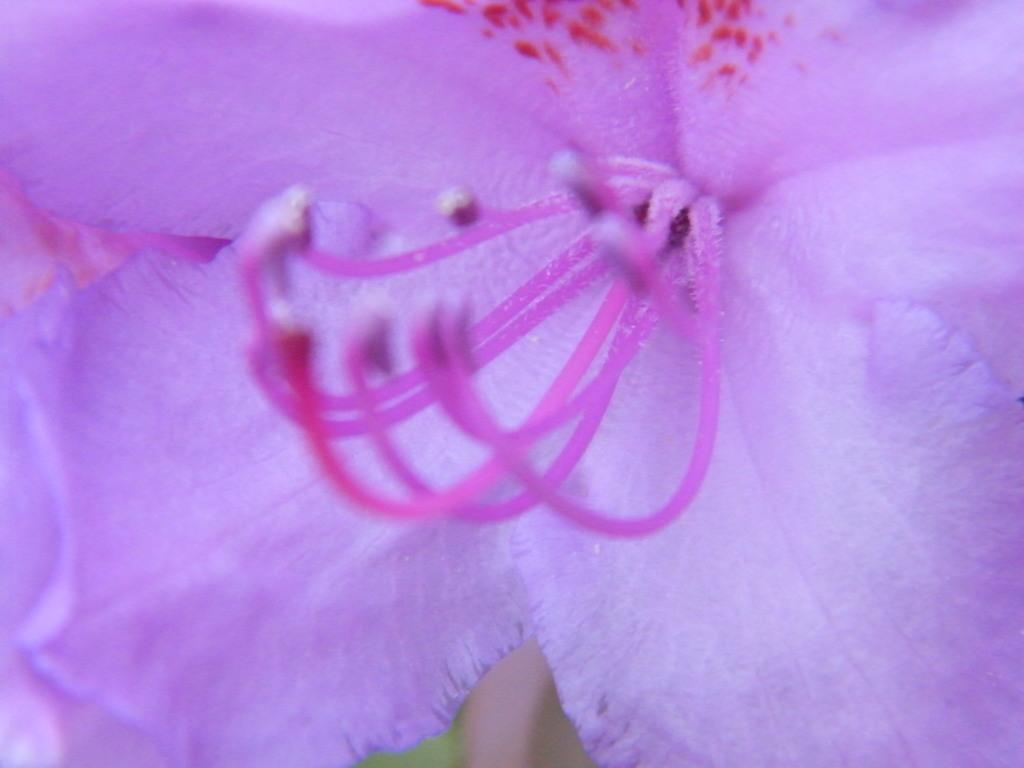What type of plant is depicted in the image? There is a flower with stamens in the image. What other part of the plant can be seen in the image? There is a green object that resembles a leaf in the image. Where is the leaf located in relation to the flower? The leaf is on the ground. What type of magic is being performed on the flower in the image? There is no magic being performed on the flower in the image; it is a natural plant. 